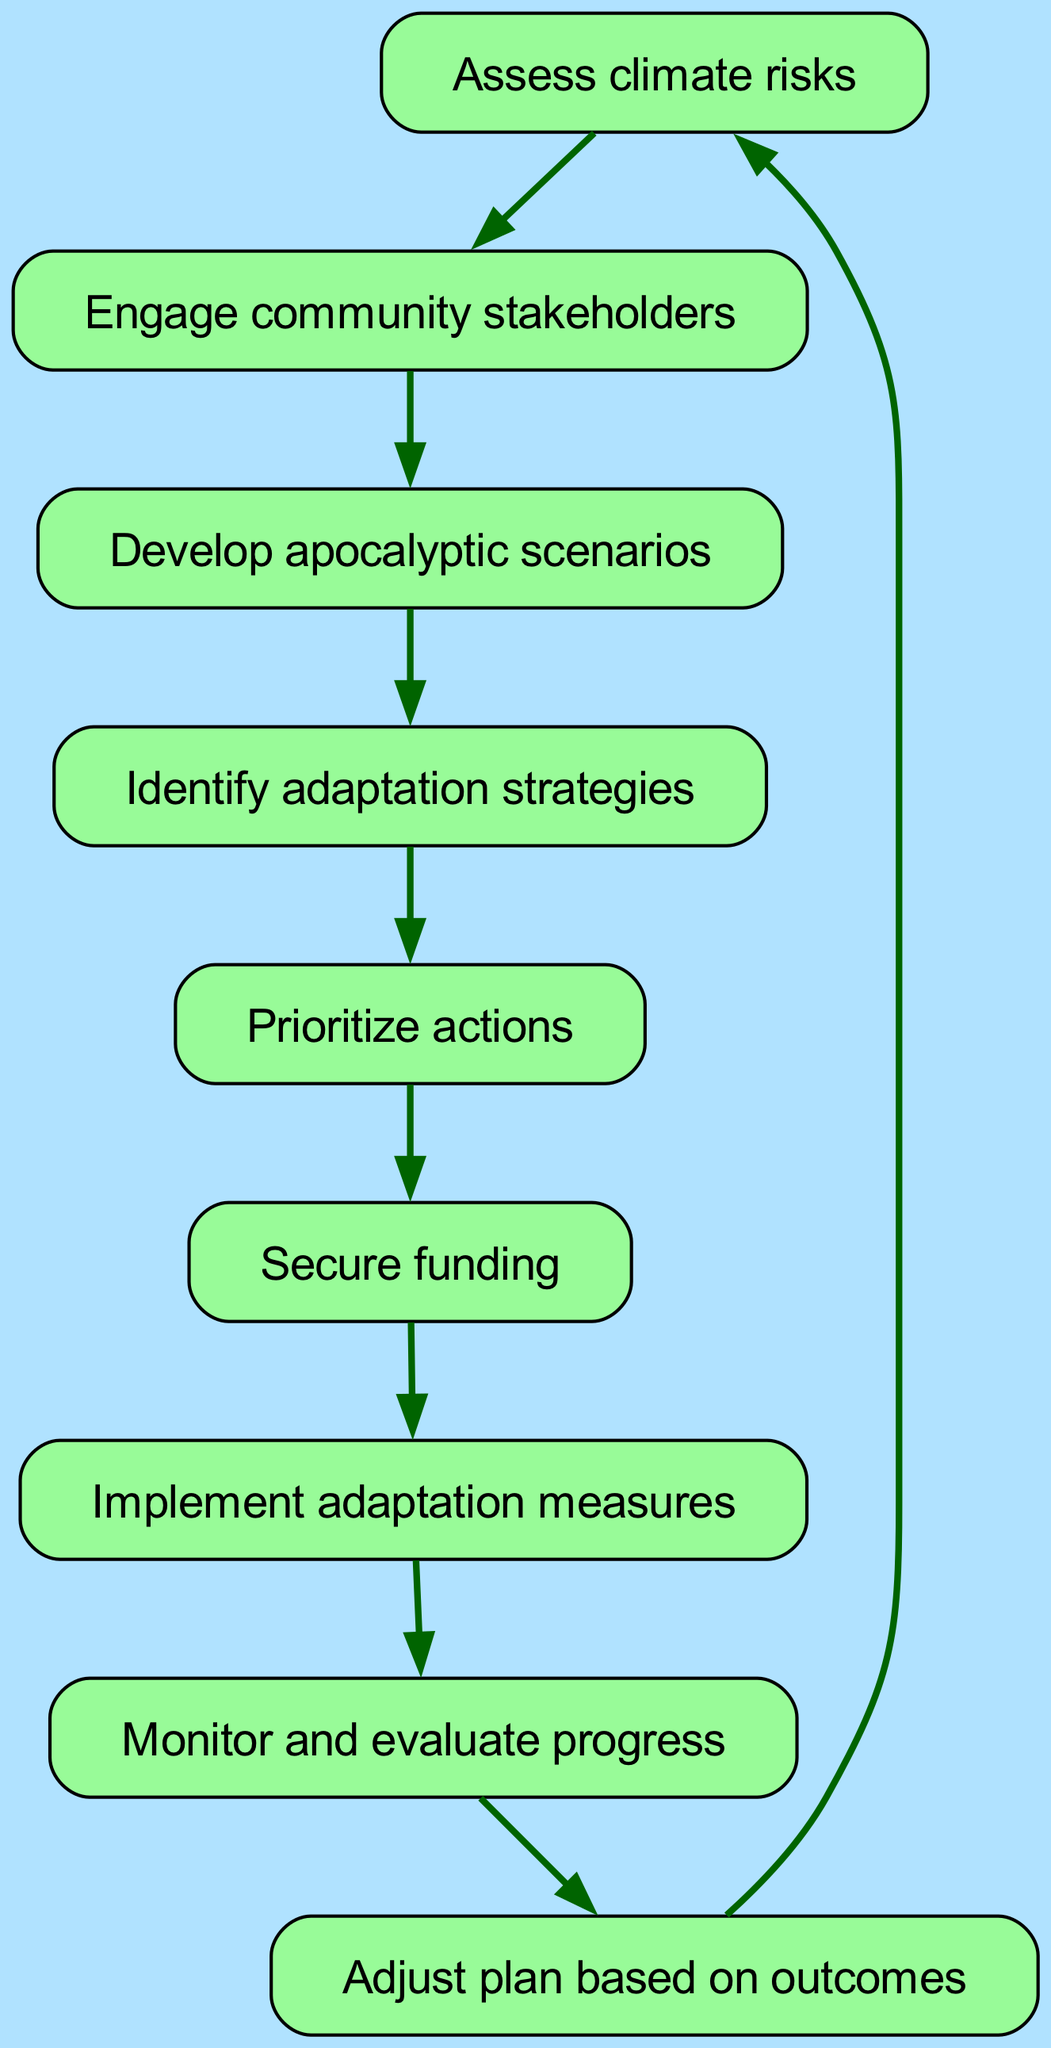What is the first step in the flow chart? The first step is labeled and directly visible as "Assess climate risks" in the diagram.
Answer: Assess climate risks How many nodes are present in the flow chart? By counting the distinct labeled nodes in the diagram, there are nine nodes in total representing each stage.
Answer: 9 Which step follows "Identify adaptation strategies"? The flow chart shows that the step immediately following "Identify adaptation strategies" is "Prioritize actions" as indicated by the directed edge.
Answer: Prioritize actions What is the final step before returning to the first step? The last step before returning to the beginning of the cycle is "Adjust plan based on outcomes," as it leads back to the initial step of assessing climate risks.
Answer: Adjust plan based on outcomes Explain the connection between "Develop apocalyptic scenarios" and "Identify adaptation strategies". "Develop apocalyptic scenarios" leads directly to "Identify adaptation strategies," indicating that creating these scenarios informs the selection of strategies.
Answer: Identify adaptation strategies How many connections lead out from "Secure funding"? There is one directed connection leading out from "Secure funding," which points to the next step "Implement adaptation measures."
Answer: 1 What stage requires community involvement? The stage "Engage community stakeholders" explicitly mentions the involvement of community members, making it crucial for the process.
Answer: Engage community stakeholders Which step comes before monitoring and evaluation? The step that comes immediately before "Monitor and evaluate progress" in the instructional flow is "Implement adaptation measures," showing that evaluation is done after implementation.
Answer: Implement adaptation measures Discuss the circularity of the process in the flow chart. The flow chart displays a circular process where the last step "Adjust plan based on outcomes" connects back to the first node, creating an iterative cycle of continuous improvement.
Answer: Circular process 